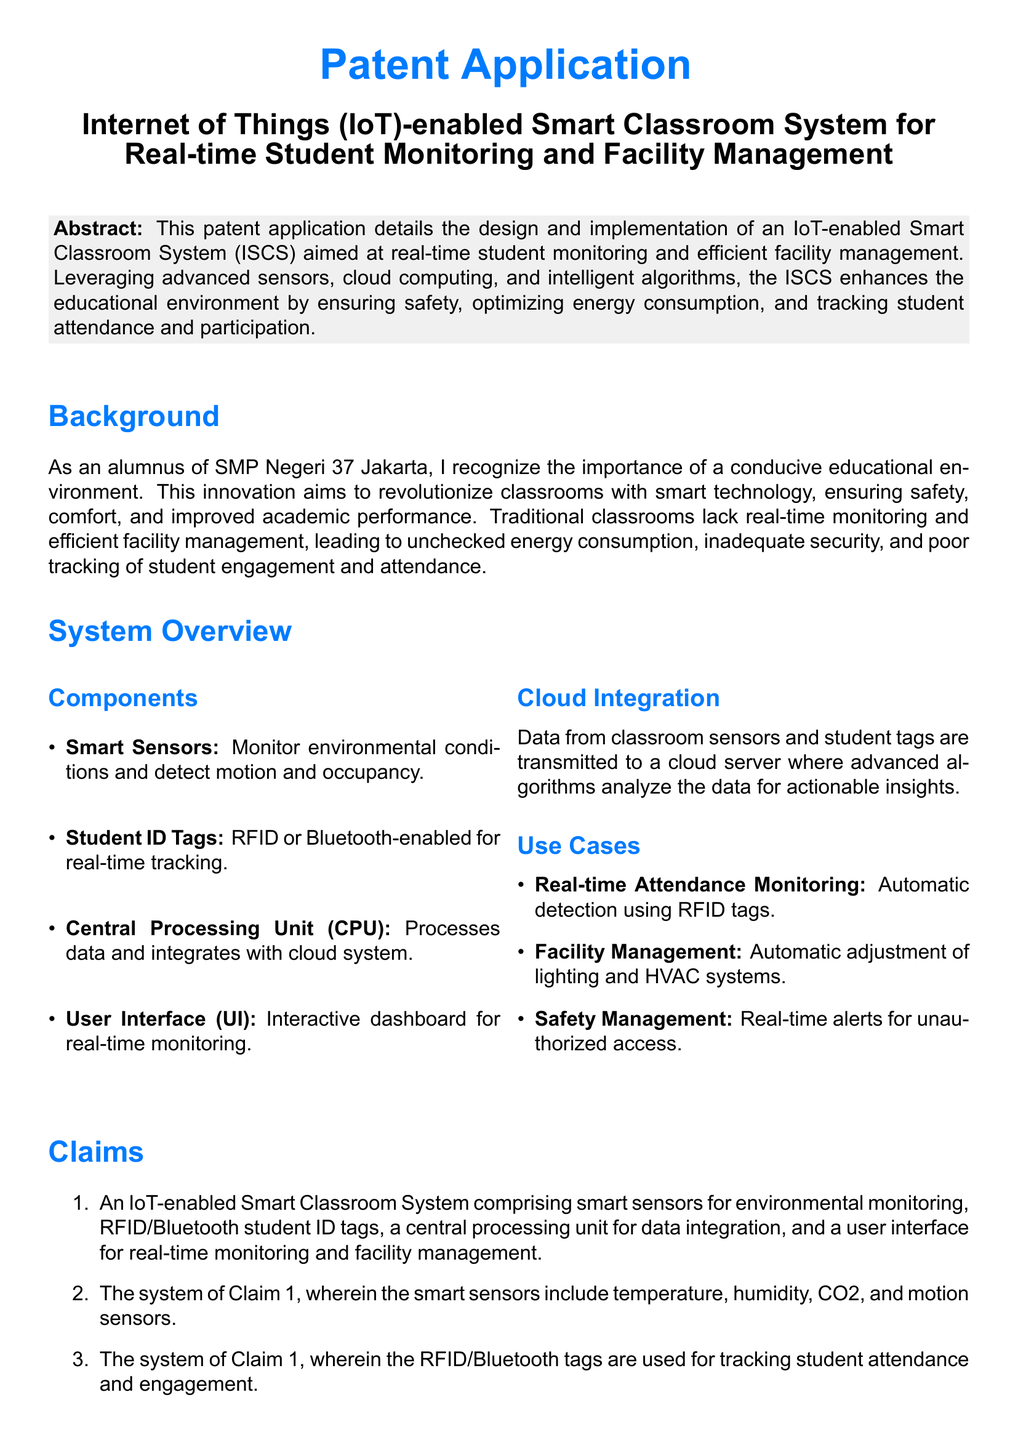What is the main focus of the patent application? The patent application focuses on an IoT-enabled Smart Classroom System aimed at real-time student monitoring and efficient facility management.
Answer: IoT-enabled Smart Classroom System What sensors are mentioned for environmental monitoring? The smart sensors include temperature, humidity, CO2, and motion sensors as per Claim 2.
Answer: Temperature, humidity, CO2, and motion sensors What technology is used for tracking student attendance? The technology used for tracking student attendance is RFID or Bluetooth-enabled student ID tags.
Answer: RFID or Bluetooth-enabled student ID tags What is the purpose of cloud integration in the system? Cloud integration is used for transmitting data from classroom sensors and student tags to analyze data for actionable insights.
Answer: Analyze data for actionable insights How does the system enhance safety management? The system enhances safety management by providing real-time alerts for unauthorized access.
Answer: Real-time alerts for unauthorized access What does ISCS stand for? ISCS stands for IoT-enabled Smart Classroom System.
Answer: IoT-enabled Smart Classroom System What kind of interface does the system provide? The system provides an interactive dashboard for real-time monitoring.
Answer: Interactive dashboard What is the claimed benefit of optimizing energy consumption in the document? Optimizing energy consumption is one of the key benefits stated in the claims of the system related to managing facility energy consumption.
Answer: Managing facility energy consumption 